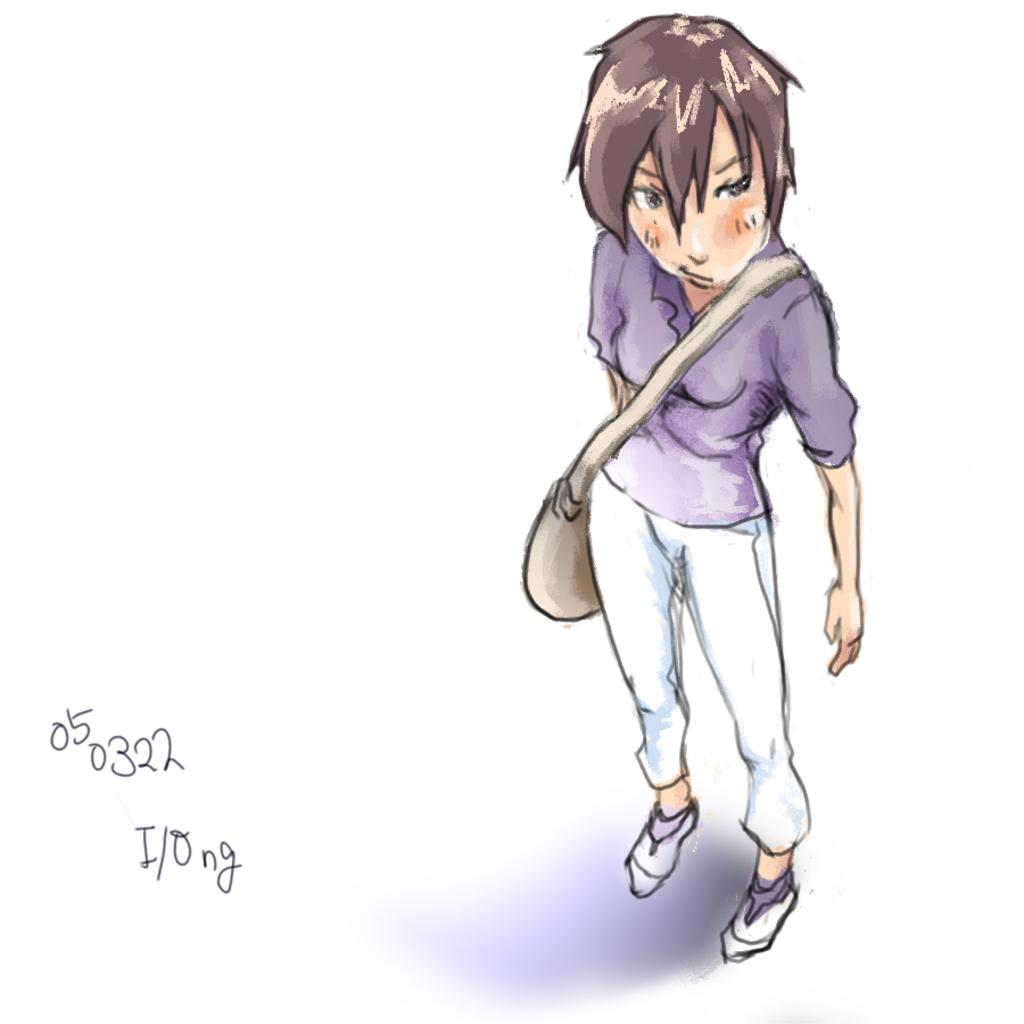What is the main subject of the image? There is a painting in the image. What does the painting depict? The painting depicts a person. Are there any additional elements on the painting? Yes, there is text written on the painting. What type of nut is being used as a prop in the painting? There is no nut present in the painting; it depicts a person with text written on it. 